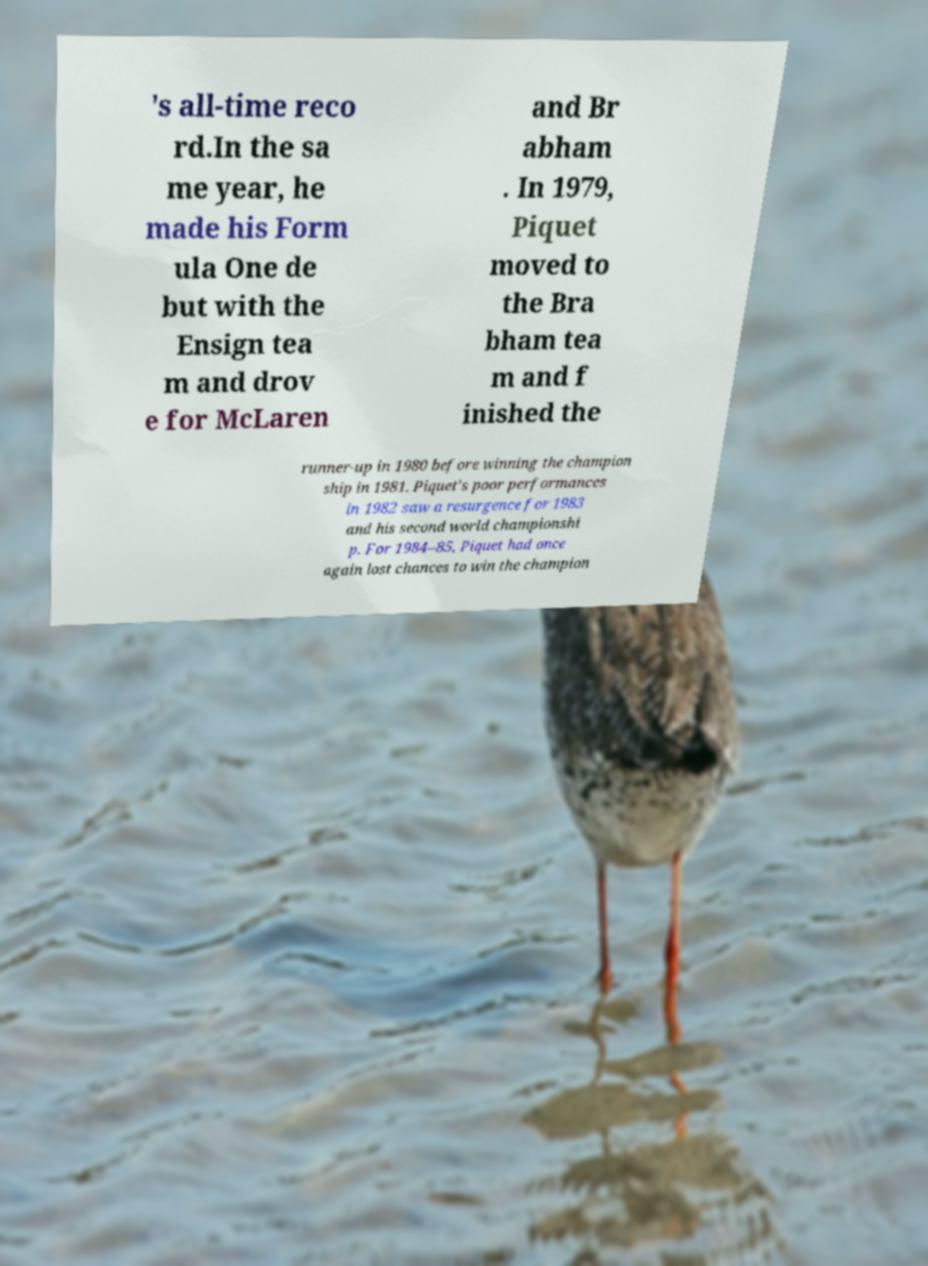Can you read and provide the text displayed in the image?This photo seems to have some interesting text. Can you extract and type it out for me? 's all-time reco rd.In the sa me year, he made his Form ula One de but with the Ensign tea m and drov e for McLaren and Br abham . In 1979, Piquet moved to the Bra bham tea m and f inished the runner-up in 1980 before winning the champion ship in 1981. Piquet's poor performances in 1982 saw a resurgence for 1983 and his second world championshi p. For 1984–85, Piquet had once again lost chances to win the champion 